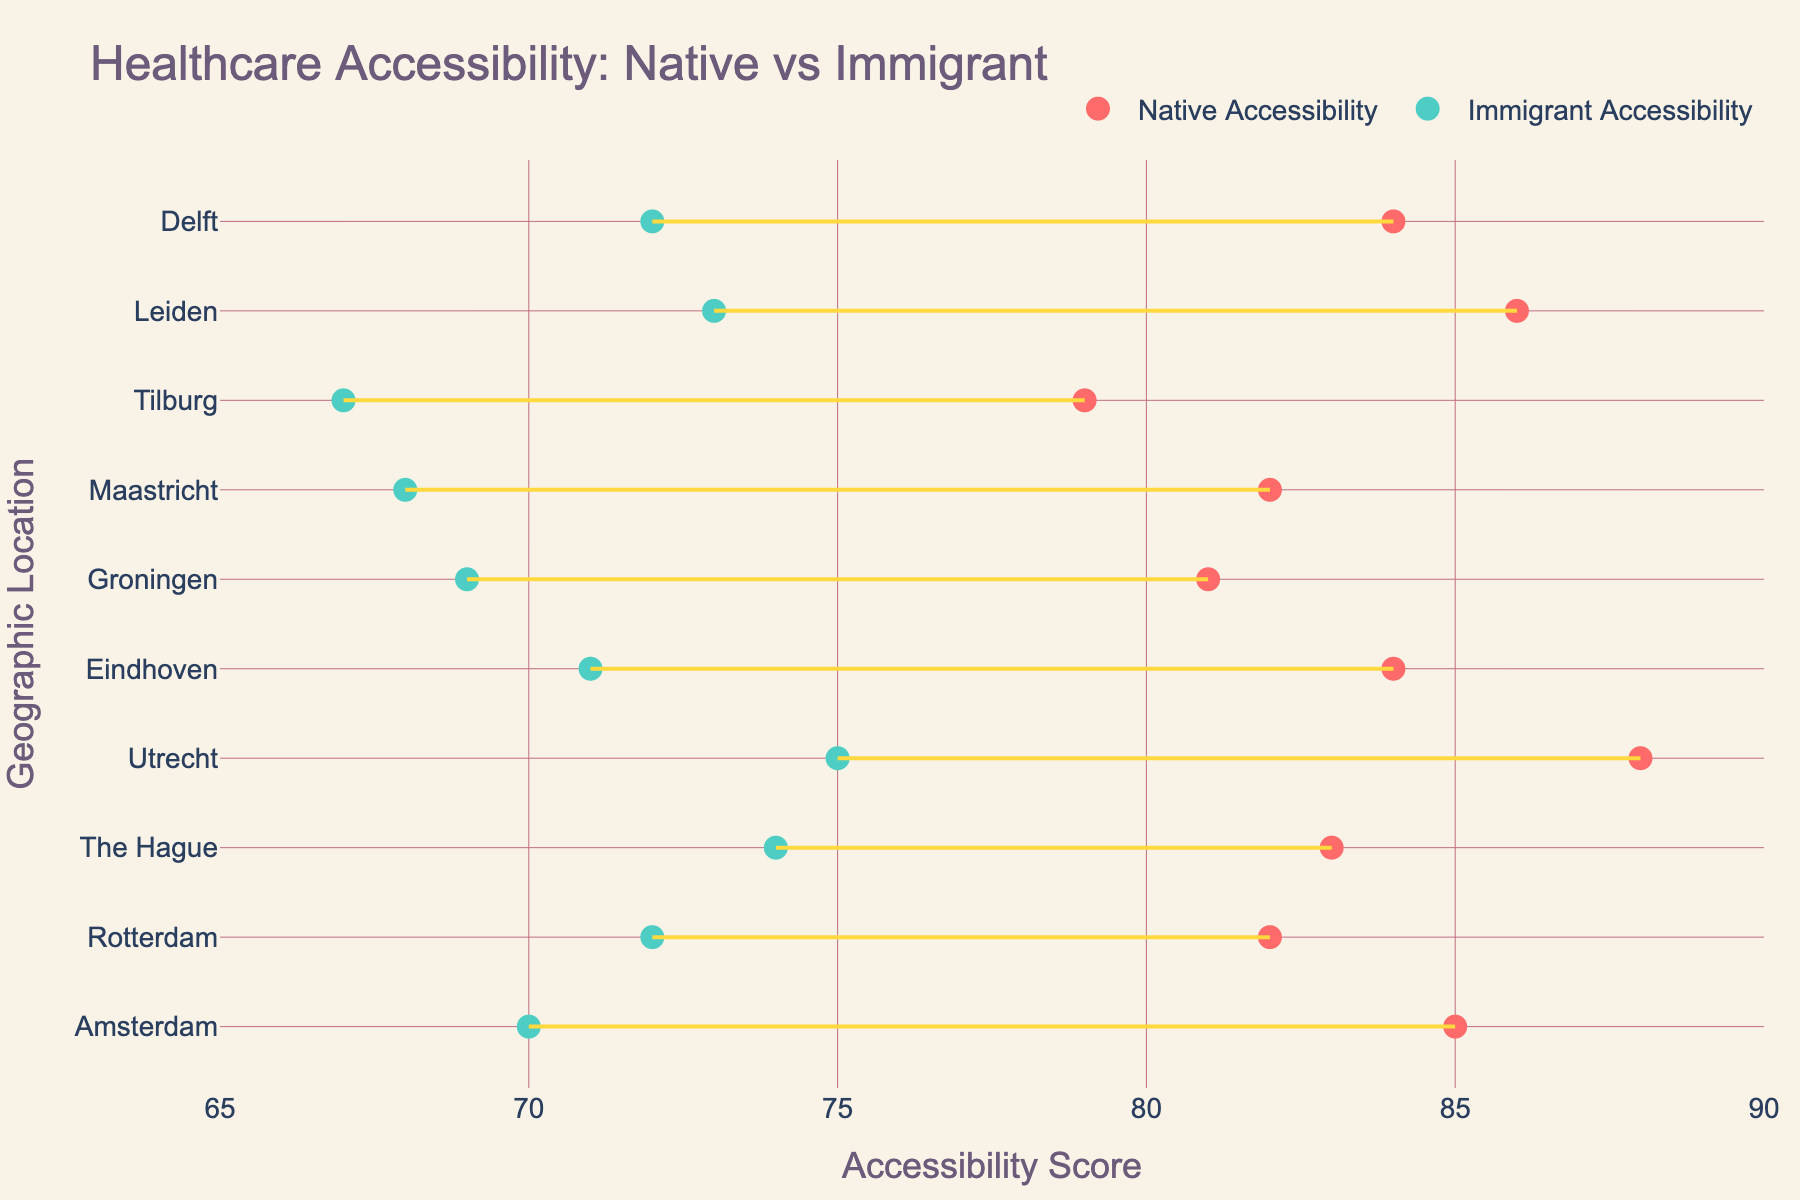What is the title of the figure? The title of the figure is prominently displayed at the top of the plot, which states, "Healthcare Accessibility: Native vs Immigrant".
Answer: Healthcare Accessibility: Native vs Immigrant Which geographic location has the highest native accessibility score? By examining the x-axis points for Native Accessibility and their corresponding locations, Utrecht has the highest score of 88.
Answer: Utrecht What is the accessibility score gap between native residents and immigrants in Amsterdam? To find the gap, subtract the immigrant accessibility score (70) from the native accessibility score (85) for Amsterdam.
Answer: 15 Which geographic location has the smallest difference in accessibility scores between natives and immigrants? By visually comparing the gaps between the scores for all locations, Maastricht has the smallest difference between the native (82) and immigrant (68) scores, which is 14.
Answer: Maastricht Is there any location where immigrant accessibility score is higher than native accessibility score? By checking all points, none of the immigrant scores exceed their respective native scores in any location.
Answer: No Which geographic location has the second-highest immigrant accessibility score? By ranking the immigrant scores, Utrecht has the highest (75) and The Hague has the second-highest (74).
Answer: The Hague What is the average satisfaction score for native residents across all locations? Sum all native satisfaction scores (88 + 85 + 87 + 90 + 86 + 84 + 83 + 82 + 89 + 87 = 861) and divide by the number of locations (10).
Answer: 86.1 Between Rotterdam and Eindhoven, which city has a greater difference in accessibility scores between native and immigrant residents? Calculate the differences for both: Rotterdam (82 - 72 = 10) and Eindhoven (84 - 71 = 13). Eindhoven has a greater difference.
Answer: Eindhoven How does the accessibility gap in Utrecht compare to the gap in Leiden? Calculate gaps for both: Utrecht (88 - 75 = 13) and Leiden (86 - 73 = 13). Both have the same gap.
Answer: Same Which cities have an immigrant satisfaction score greater than 75? By examining the Immigrant Satisfaction scores, The Hague (80), Rotterdam (78), Utrecht (79), Eindhoven (77), and Delft (77) all have scores greater than 75.
Answer: The Hague, Rotterdam, Utrecht, Eindhoven, Delft 